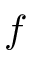Convert formula to latex. <formula><loc_0><loc_0><loc_500><loc_500>f</formula> 